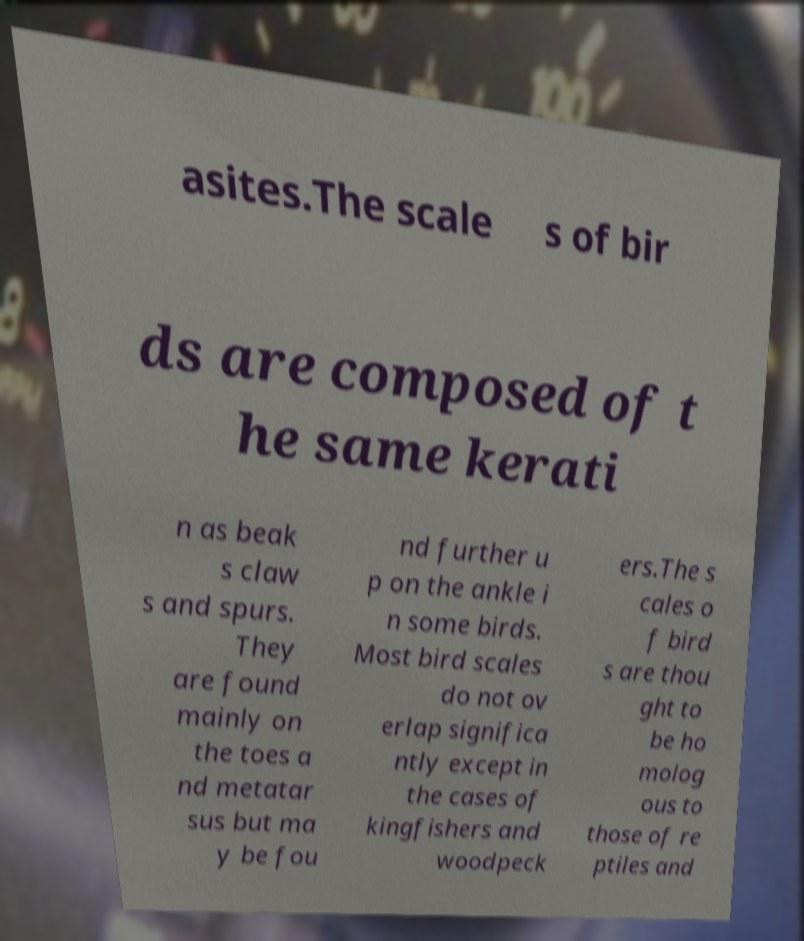Please read and relay the text visible in this image. What does it say? asites.The scale s of bir ds are composed of t he same kerati n as beak s claw s and spurs. They are found mainly on the toes a nd metatar sus but ma y be fou nd further u p on the ankle i n some birds. Most bird scales do not ov erlap significa ntly except in the cases of kingfishers and woodpeck ers.The s cales o f bird s are thou ght to be ho molog ous to those of re ptiles and 